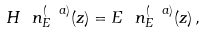<formula> <loc_0><loc_0><loc_500><loc_500>H \ n _ { E } ^ { ( \ a ) } ( z ) = E \ n _ { E } ^ { ( \ a ) } ( z ) \, ,</formula> 